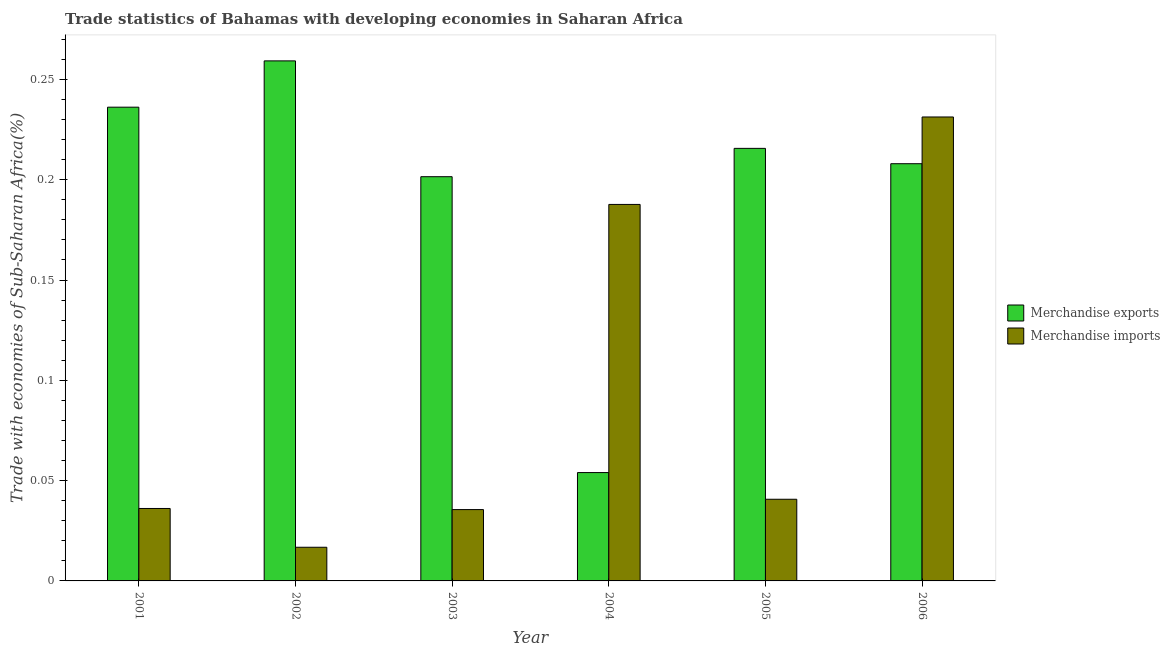How many different coloured bars are there?
Offer a terse response. 2. Are the number of bars per tick equal to the number of legend labels?
Provide a succinct answer. Yes. How many bars are there on the 4th tick from the left?
Your answer should be compact. 2. How many bars are there on the 6th tick from the right?
Make the answer very short. 2. What is the merchandise exports in 2005?
Offer a terse response. 0.22. Across all years, what is the maximum merchandise exports?
Provide a short and direct response. 0.26. Across all years, what is the minimum merchandise exports?
Provide a succinct answer. 0.05. In which year was the merchandise exports maximum?
Offer a very short reply. 2002. In which year was the merchandise imports minimum?
Offer a very short reply. 2002. What is the total merchandise imports in the graph?
Provide a short and direct response. 0.55. What is the difference between the merchandise imports in 2002 and that in 2004?
Your response must be concise. -0.17. What is the difference between the merchandise exports in 2001 and the merchandise imports in 2004?
Give a very brief answer. 0.18. What is the average merchandise imports per year?
Make the answer very short. 0.09. In the year 2005, what is the difference between the merchandise imports and merchandise exports?
Your response must be concise. 0. In how many years, is the merchandise exports greater than 0.14 %?
Offer a terse response. 5. What is the ratio of the merchandise exports in 2001 to that in 2006?
Provide a succinct answer. 1.14. Is the difference between the merchandise exports in 2004 and 2005 greater than the difference between the merchandise imports in 2004 and 2005?
Provide a succinct answer. No. What is the difference between the highest and the second highest merchandise exports?
Keep it short and to the point. 0.02. What is the difference between the highest and the lowest merchandise exports?
Offer a very short reply. 0.21. In how many years, is the merchandise imports greater than the average merchandise imports taken over all years?
Keep it short and to the point. 2. What does the 2nd bar from the left in 2001 represents?
Provide a succinct answer. Merchandise imports. Are all the bars in the graph horizontal?
Your answer should be compact. No. Are the values on the major ticks of Y-axis written in scientific E-notation?
Give a very brief answer. No. Does the graph contain any zero values?
Your answer should be compact. No. How are the legend labels stacked?
Your answer should be compact. Vertical. What is the title of the graph?
Your answer should be very brief. Trade statistics of Bahamas with developing economies in Saharan Africa. What is the label or title of the X-axis?
Offer a very short reply. Year. What is the label or title of the Y-axis?
Your answer should be very brief. Trade with economies of Sub-Saharan Africa(%). What is the Trade with economies of Sub-Saharan Africa(%) of Merchandise exports in 2001?
Ensure brevity in your answer.  0.24. What is the Trade with economies of Sub-Saharan Africa(%) in Merchandise imports in 2001?
Ensure brevity in your answer.  0.04. What is the Trade with economies of Sub-Saharan Africa(%) of Merchandise exports in 2002?
Keep it short and to the point. 0.26. What is the Trade with economies of Sub-Saharan Africa(%) of Merchandise imports in 2002?
Give a very brief answer. 0.02. What is the Trade with economies of Sub-Saharan Africa(%) in Merchandise exports in 2003?
Make the answer very short. 0.2. What is the Trade with economies of Sub-Saharan Africa(%) of Merchandise imports in 2003?
Make the answer very short. 0.04. What is the Trade with economies of Sub-Saharan Africa(%) in Merchandise exports in 2004?
Offer a terse response. 0.05. What is the Trade with economies of Sub-Saharan Africa(%) in Merchandise imports in 2004?
Offer a very short reply. 0.19. What is the Trade with economies of Sub-Saharan Africa(%) of Merchandise exports in 2005?
Offer a terse response. 0.22. What is the Trade with economies of Sub-Saharan Africa(%) in Merchandise imports in 2005?
Your answer should be compact. 0.04. What is the Trade with economies of Sub-Saharan Africa(%) in Merchandise exports in 2006?
Provide a succinct answer. 0.21. What is the Trade with economies of Sub-Saharan Africa(%) of Merchandise imports in 2006?
Offer a very short reply. 0.23. Across all years, what is the maximum Trade with economies of Sub-Saharan Africa(%) of Merchandise exports?
Your answer should be very brief. 0.26. Across all years, what is the maximum Trade with economies of Sub-Saharan Africa(%) of Merchandise imports?
Keep it short and to the point. 0.23. Across all years, what is the minimum Trade with economies of Sub-Saharan Africa(%) of Merchandise exports?
Your response must be concise. 0.05. Across all years, what is the minimum Trade with economies of Sub-Saharan Africa(%) in Merchandise imports?
Offer a terse response. 0.02. What is the total Trade with economies of Sub-Saharan Africa(%) of Merchandise exports in the graph?
Your response must be concise. 1.17. What is the total Trade with economies of Sub-Saharan Africa(%) in Merchandise imports in the graph?
Provide a short and direct response. 0.55. What is the difference between the Trade with economies of Sub-Saharan Africa(%) in Merchandise exports in 2001 and that in 2002?
Ensure brevity in your answer.  -0.02. What is the difference between the Trade with economies of Sub-Saharan Africa(%) of Merchandise imports in 2001 and that in 2002?
Make the answer very short. 0.02. What is the difference between the Trade with economies of Sub-Saharan Africa(%) in Merchandise exports in 2001 and that in 2003?
Your response must be concise. 0.03. What is the difference between the Trade with economies of Sub-Saharan Africa(%) of Merchandise imports in 2001 and that in 2003?
Provide a short and direct response. 0. What is the difference between the Trade with economies of Sub-Saharan Africa(%) of Merchandise exports in 2001 and that in 2004?
Your response must be concise. 0.18. What is the difference between the Trade with economies of Sub-Saharan Africa(%) of Merchandise imports in 2001 and that in 2004?
Provide a succinct answer. -0.15. What is the difference between the Trade with economies of Sub-Saharan Africa(%) in Merchandise exports in 2001 and that in 2005?
Make the answer very short. 0.02. What is the difference between the Trade with economies of Sub-Saharan Africa(%) in Merchandise imports in 2001 and that in 2005?
Your response must be concise. -0. What is the difference between the Trade with economies of Sub-Saharan Africa(%) in Merchandise exports in 2001 and that in 2006?
Ensure brevity in your answer.  0.03. What is the difference between the Trade with economies of Sub-Saharan Africa(%) of Merchandise imports in 2001 and that in 2006?
Your answer should be compact. -0.2. What is the difference between the Trade with economies of Sub-Saharan Africa(%) in Merchandise exports in 2002 and that in 2003?
Your answer should be very brief. 0.06. What is the difference between the Trade with economies of Sub-Saharan Africa(%) of Merchandise imports in 2002 and that in 2003?
Keep it short and to the point. -0.02. What is the difference between the Trade with economies of Sub-Saharan Africa(%) in Merchandise exports in 2002 and that in 2004?
Offer a terse response. 0.21. What is the difference between the Trade with economies of Sub-Saharan Africa(%) in Merchandise imports in 2002 and that in 2004?
Provide a succinct answer. -0.17. What is the difference between the Trade with economies of Sub-Saharan Africa(%) of Merchandise exports in 2002 and that in 2005?
Provide a succinct answer. 0.04. What is the difference between the Trade with economies of Sub-Saharan Africa(%) of Merchandise imports in 2002 and that in 2005?
Your response must be concise. -0.02. What is the difference between the Trade with economies of Sub-Saharan Africa(%) of Merchandise exports in 2002 and that in 2006?
Provide a short and direct response. 0.05. What is the difference between the Trade with economies of Sub-Saharan Africa(%) in Merchandise imports in 2002 and that in 2006?
Your answer should be very brief. -0.21. What is the difference between the Trade with economies of Sub-Saharan Africa(%) in Merchandise exports in 2003 and that in 2004?
Make the answer very short. 0.15. What is the difference between the Trade with economies of Sub-Saharan Africa(%) of Merchandise imports in 2003 and that in 2004?
Your answer should be compact. -0.15. What is the difference between the Trade with economies of Sub-Saharan Africa(%) of Merchandise exports in 2003 and that in 2005?
Offer a very short reply. -0.01. What is the difference between the Trade with economies of Sub-Saharan Africa(%) of Merchandise imports in 2003 and that in 2005?
Give a very brief answer. -0.01. What is the difference between the Trade with economies of Sub-Saharan Africa(%) of Merchandise exports in 2003 and that in 2006?
Your response must be concise. -0.01. What is the difference between the Trade with economies of Sub-Saharan Africa(%) of Merchandise imports in 2003 and that in 2006?
Provide a short and direct response. -0.2. What is the difference between the Trade with economies of Sub-Saharan Africa(%) in Merchandise exports in 2004 and that in 2005?
Your answer should be very brief. -0.16. What is the difference between the Trade with economies of Sub-Saharan Africa(%) of Merchandise imports in 2004 and that in 2005?
Ensure brevity in your answer.  0.15. What is the difference between the Trade with economies of Sub-Saharan Africa(%) in Merchandise exports in 2004 and that in 2006?
Offer a terse response. -0.15. What is the difference between the Trade with economies of Sub-Saharan Africa(%) of Merchandise imports in 2004 and that in 2006?
Keep it short and to the point. -0.04. What is the difference between the Trade with economies of Sub-Saharan Africa(%) in Merchandise exports in 2005 and that in 2006?
Your answer should be compact. 0.01. What is the difference between the Trade with economies of Sub-Saharan Africa(%) of Merchandise imports in 2005 and that in 2006?
Offer a very short reply. -0.19. What is the difference between the Trade with economies of Sub-Saharan Africa(%) in Merchandise exports in 2001 and the Trade with economies of Sub-Saharan Africa(%) in Merchandise imports in 2002?
Your answer should be very brief. 0.22. What is the difference between the Trade with economies of Sub-Saharan Africa(%) of Merchandise exports in 2001 and the Trade with economies of Sub-Saharan Africa(%) of Merchandise imports in 2003?
Keep it short and to the point. 0.2. What is the difference between the Trade with economies of Sub-Saharan Africa(%) in Merchandise exports in 2001 and the Trade with economies of Sub-Saharan Africa(%) in Merchandise imports in 2004?
Give a very brief answer. 0.05. What is the difference between the Trade with economies of Sub-Saharan Africa(%) in Merchandise exports in 2001 and the Trade with economies of Sub-Saharan Africa(%) in Merchandise imports in 2005?
Keep it short and to the point. 0.2. What is the difference between the Trade with economies of Sub-Saharan Africa(%) in Merchandise exports in 2001 and the Trade with economies of Sub-Saharan Africa(%) in Merchandise imports in 2006?
Offer a terse response. 0. What is the difference between the Trade with economies of Sub-Saharan Africa(%) in Merchandise exports in 2002 and the Trade with economies of Sub-Saharan Africa(%) in Merchandise imports in 2003?
Offer a terse response. 0.22. What is the difference between the Trade with economies of Sub-Saharan Africa(%) of Merchandise exports in 2002 and the Trade with economies of Sub-Saharan Africa(%) of Merchandise imports in 2004?
Offer a very short reply. 0.07. What is the difference between the Trade with economies of Sub-Saharan Africa(%) in Merchandise exports in 2002 and the Trade with economies of Sub-Saharan Africa(%) in Merchandise imports in 2005?
Provide a succinct answer. 0.22. What is the difference between the Trade with economies of Sub-Saharan Africa(%) in Merchandise exports in 2002 and the Trade with economies of Sub-Saharan Africa(%) in Merchandise imports in 2006?
Provide a short and direct response. 0.03. What is the difference between the Trade with economies of Sub-Saharan Africa(%) of Merchandise exports in 2003 and the Trade with economies of Sub-Saharan Africa(%) of Merchandise imports in 2004?
Keep it short and to the point. 0.01. What is the difference between the Trade with economies of Sub-Saharan Africa(%) in Merchandise exports in 2003 and the Trade with economies of Sub-Saharan Africa(%) in Merchandise imports in 2005?
Your answer should be compact. 0.16. What is the difference between the Trade with economies of Sub-Saharan Africa(%) in Merchandise exports in 2003 and the Trade with economies of Sub-Saharan Africa(%) in Merchandise imports in 2006?
Provide a succinct answer. -0.03. What is the difference between the Trade with economies of Sub-Saharan Africa(%) of Merchandise exports in 2004 and the Trade with economies of Sub-Saharan Africa(%) of Merchandise imports in 2005?
Give a very brief answer. 0.01. What is the difference between the Trade with economies of Sub-Saharan Africa(%) of Merchandise exports in 2004 and the Trade with economies of Sub-Saharan Africa(%) of Merchandise imports in 2006?
Your answer should be compact. -0.18. What is the difference between the Trade with economies of Sub-Saharan Africa(%) in Merchandise exports in 2005 and the Trade with economies of Sub-Saharan Africa(%) in Merchandise imports in 2006?
Offer a very short reply. -0.02. What is the average Trade with economies of Sub-Saharan Africa(%) of Merchandise exports per year?
Provide a short and direct response. 0.2. What is the average Trade with economies of Sub-Saharan Africa(%) of Merchandise imports per year?
Give a very brief answer. 0.09. In the year 2002, what is the difference between the Trade with economies of Sub-Saharan Africa(%) in Merchandise exports and Trade with economies of Sub-Saharan Africa(%) in Merchandise imports?
Your answer should be compact. 0.24. In the year 2003, what is the difference between the Trade with economies of Sub-Saharan Africa(%) in Merchandise exports and Trade with economies of Sub-Saharan Africa(%) in Merchandise imports?
Make the answer very short. 0.17. In the year 2004, what is the difference between the Trade with economies of Sub-Saharan Africa(%) in Merchandise exports and Trade with economies of Sub-Saharan Africa(%) in Merchandise imports?
Your response must be concise. -0.13. In the year 2005, what is the difference between the Trade with economies of Sub-Saharan Africa(%) of Merchandise exports and Trade with economies of Sub-Saharan Africa(%) of Merchandise imports?
Your response must be concise. 0.17. In the year 2006, what is the difference between the Trade with economies of Sub-Saharan Africa(%) of Merchandise exports and Trade with economies of Sub-Saharan Africa(%) of Merchandise imports?
Offer a terse response. -0.02. What is the ratio of the Trade with economies of Sub-Saharan Africa(%) in Merchandise exports in 2001 to that in 2002?
Offer a very short reply. 0.91. What is the ratio of the Trade with economies of Sub-Saharan Africa(%) in Merchandise imports in 2001 to that in 2002?
Make the answer very short. 2.15. What is the ratio of the Trade with economies of Sub-Saharan Africa(%) in Merchandise exports in 2001 to that in 2003?
Keep it short and to the point. 1.17. What is the ratio of the Trade with economies of Sub-Saharan Africa(%) of Merchandise imports in 2001 to that in 2003?
Keep it short and to the point. 1.02. What is the ratio of the Trade with economies of Sub-Saharan Africa(%) in Merchandise exports in 2001 to that in 2004?
Offer a terse response. 4.37. What is the ratio of the Trade with economies of Sub-Saharan Africa(%) of Merchandise imports in 2001 to that in 2004?
Your answer should be very brief. 0.19. What is the ratio of the Trade with economies of Sub-Saharan Africa(%) in Merchandise exports in 2001 to that in 2005?
Ensure brevity in your answer.  1.1. What is the ratio of the Trade with economies of Sub-Saharan Africa(%) in Merchandise imports in 2001 to that in 2005?
Provide a succinct answer. 0.89. What is the ratio of the Trade with economies of Sub-Saharan Africa(%) in Merchandise exports in 2001 to that in 2006?
Your answer should be very brief. 1.14. What is the ratio of the Trade with economies of Sub-Saharan Africa(%) in Merchandise imports in 2001 to that in 2006?
Give a very brief answer. 0.16. What is the ratio of the Trade with economies of Sub-Saharan Africa(%) in Merchandise exports in 2002 to that in 2003?
Give a very brief answer. 1.29. What is the ratio of the Trade with economies of Sub-Saharan Africa(%) in Merchandise imports in 2002 to that in 2003?
Provide a succinct answer. 0.47. What is the ratio of the Trade with economies of Sub-Saharan Africa(%) in Merchandise exports in 2002 to that in 2004?
Provide a short and direct response. 4.8. What is the ratio of the Trade with economies of Sub-Saharan Africa(%) of Merchandise imports in 2002 to that in 2004?
Provide a short and direct response. 0.09. What is the ratio of the Trade with economies of Sub-Saharan Africa(%) in Merchandise exports in 2002 to that in 2005?
Ensure brevity in your answer.  1.2. What is the ratio of the Trade with economies of Sub-Saharan Africa(%) of Merchandise imports in 2002 to that in 2005?
Your answer should be compact. 0.41. What is the ratio of the Trade with economies of Sub-Saharan Africa(%) in Merchandise exports in 2002 to that in 2006?
Provide a short and direct response. 1.25. What is the ratio of the Trade with economies of Sub-Saharan Africa(%) in Merchandise imports in 2002 to that in 2006?
Provide a succinct answer. 0.07. What is the ratio of the Trade with economies of Sub-Saharan Africa(%) in Merchandise exports in 2003 to that in 2004?
Make the answer very short. 3.73. What is the ratio of the Trade with economies of Sub-Saharan Africa(%) in Merchandise imports in 2003 to that in 2004?
Ensure brevity in your answer.  0.19. What is the ratio of the Trade with economies of Sub-Saharan Africa(%) of Merchandise exports in 2003 to that in 2005?
Your answer should be very brief. 0.93. What is the ratio of the Trade with economies of Sub-Saharan Africa(%) in Merchandise imports in 2003 to that in 2005?
Your answer should be very brief. 0.87. What is the ratio of the Trade with economies of Sub-Saharan Africa(%) of Merchandise exports in 2003 to that in 2006?
Your answer should be very brief. 0.97. What is the ratio of the Trade with economies of Sub-Saharan Africa(%) of Merchandise imports in 2003 to that in 2006?
Provide a succinct answer. 0.15. What is the ratio of the Trade with economies of Sub-Saharan Africa(%) in Merchandise exports in 2004 to that in 2005?
Ensure brevity in your answer.  0.25. What is the ratio of the Trade with economies of Sub-Saharan Africa(%) of Merchandise imports in 2004 to that in 2005?
Your response must be concise. 4.61. What is the ratio of the Trade with economies of Sub-Saharan Africa(%) in Merchandise exports in 2004 to that in 2006?
Your answer should be compact. 0.26. What is the ratio of the Trade with economies of Sub-Saharan Africa(%) of Merchandise imports in 2004 to that in 2006?
Ensure brevity in your answer.  0.81. What is the ratio of the Trade with economies of Sub-Saharan Africa(%) of Merchandise exports in 2005 to that in 2006?
Your response must be concise. 1.04. What is the ratio of the Trade with economies of Sub-Saharan Africa(%) of Merchandise imports in 2005 to that in 2006?
Offer a terse response. 0.18. What is the difference between the highest and the second highest Trade with economies of Sub-Saharan Africa(%) in Merchandise exports?
Offer a terse response. 0.02. What is the difference between the highest and the second highest Trade with economies of Sub-Saharan Africa(%) of Merchandise imports?
Provide a succinct answer. 0.04. What is the difference between the highest and the lowest Trade with economies of Sub-Saharan Africa(%) of Merchandise exports?
Offer a terse response. 0.21. What is the difference between the highest and the lowest Trade with economies of Sub-Saharan Africa(%) of Merchandise imports?
Provide a succinct answer. 0.21. 